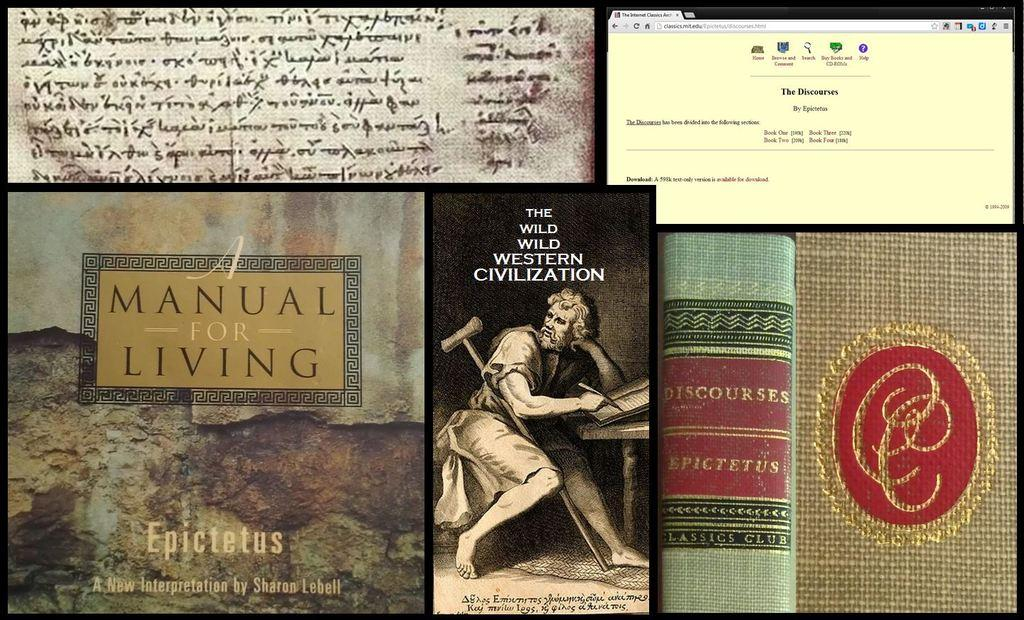<image>
Share a concise interpretation of the image provided. A collection of books about living a manual life. 